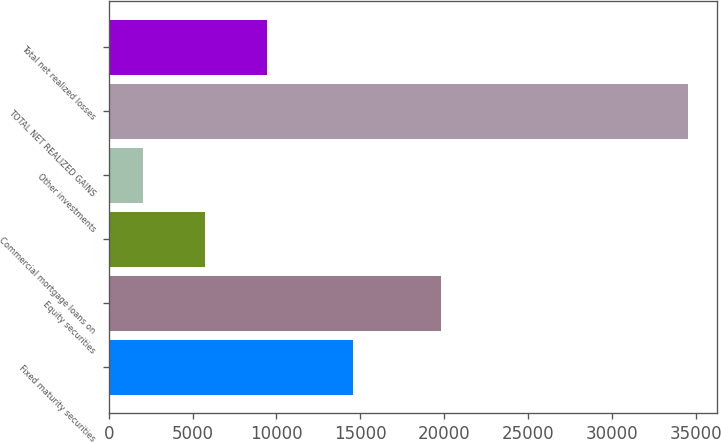Convert chart to OTSL. <chart><loc_0><loc_0><loc_500><loc_500><bar_chart><fcel>Fixed maturity securities<fcel>Equity securities<fcel>Commercial mortgage loans on<fcel>Other investments<fcel>TOTAL NET REALIZED GAINS<fcel>Total net realized losses<nl><fcel>14579<fcel>19789<fcel>5717.3<fcel>2029<fcel>34525<fcel>9405.6<nl></chart> 